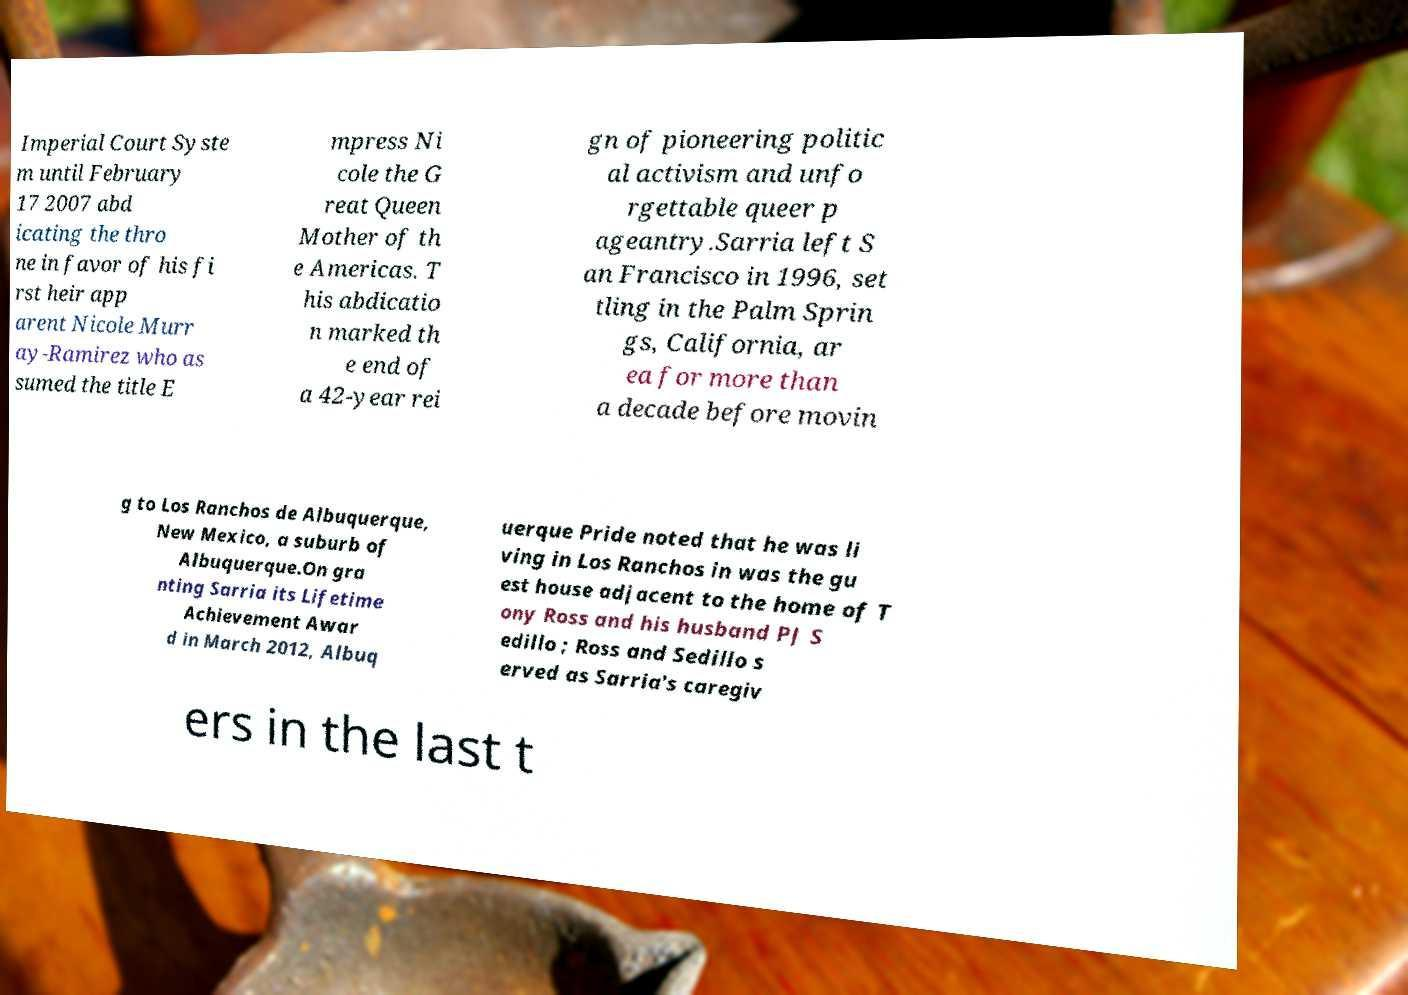For documentation purposes, I need the text within this image transcribed. Could you provide that? Imperial Court Syste m until February 17 2007 abd icating the thro ne in favor of his fi rst heir app arent Nicole Murr ay-Ramirez who as sumed the title E mpress Ni cole the G reat Queen Mother of th e Americas. T his abdicatio n marked th e end of a 42-year rei gn of pioneering politic al activism and unfo rgettable queer p ageantry.Sarria left S an Francisco in 1996, set tling in the Palm Sprin gs, California, ar ea for more than a decade before movin g to Los Ranchos de Albuquerque, New Mexico, a suburb of Albuquerque.On gra nting Sarria its Lifetime Achievement Awar d in March 2012, Albuq uerque Pride noted that he was li ving in Los Ranchos in was the gu est house adjacent to the home of T ony Ross and his husband PJ S edillo ; Ross and Sedillo s erved as Sarria's caregiv ers in the last t 